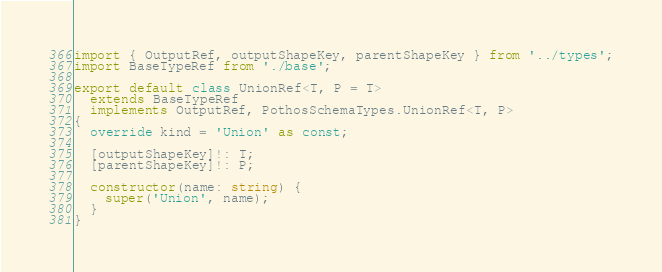Convert code to text. <code><loc_0><loc_0><loc_500><loc_500><_TypeScript_>import { OutputRef, outputShapeKey, parentShapeKey } from '../types';
import BaseTypeRef from './base';

export default class UnionRef<T, P = T>
  extends BaseTypeRef
  implements OutputRef, PothosSchemaTypes.UnionRef<T, P>
{
  override kind = 'Union' as const;

  [outputShapeKey]!: T;
  [parentShapeKey]!: P;

  constructor(name: string) {
    super('Union', name);
  }
}
</code> 